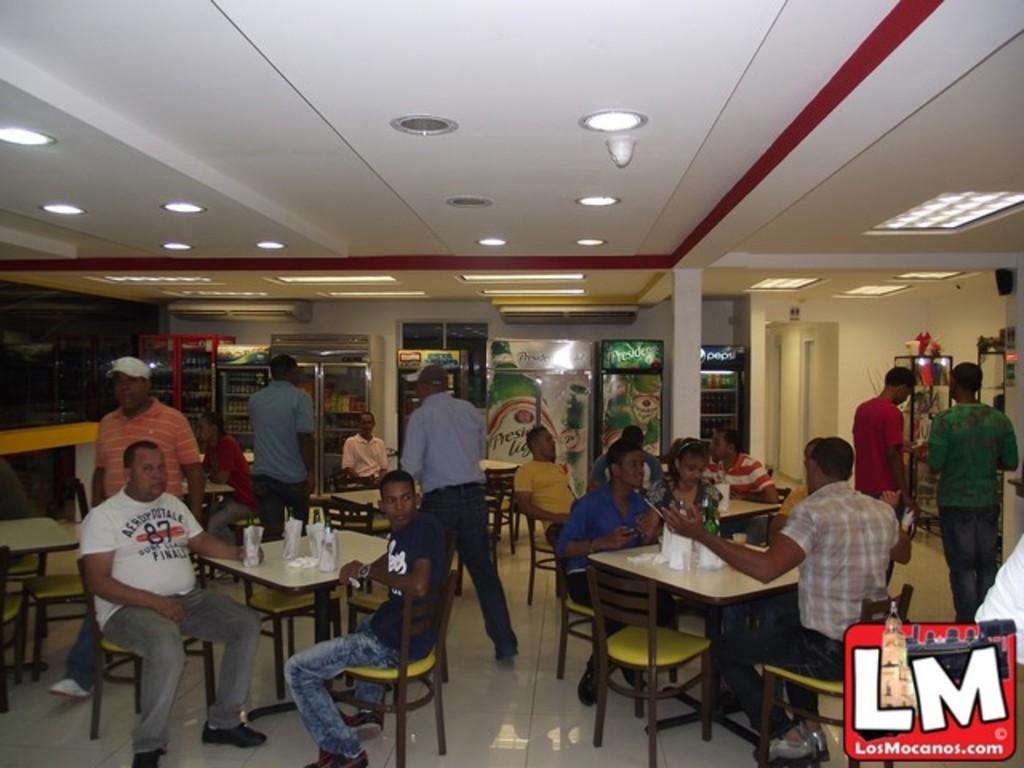Could you give a brief overview of what you see in this image? in the picture there is a restaurant in that many people are present some people are sitting on the chair and other people are walking there are many items present on the table. 